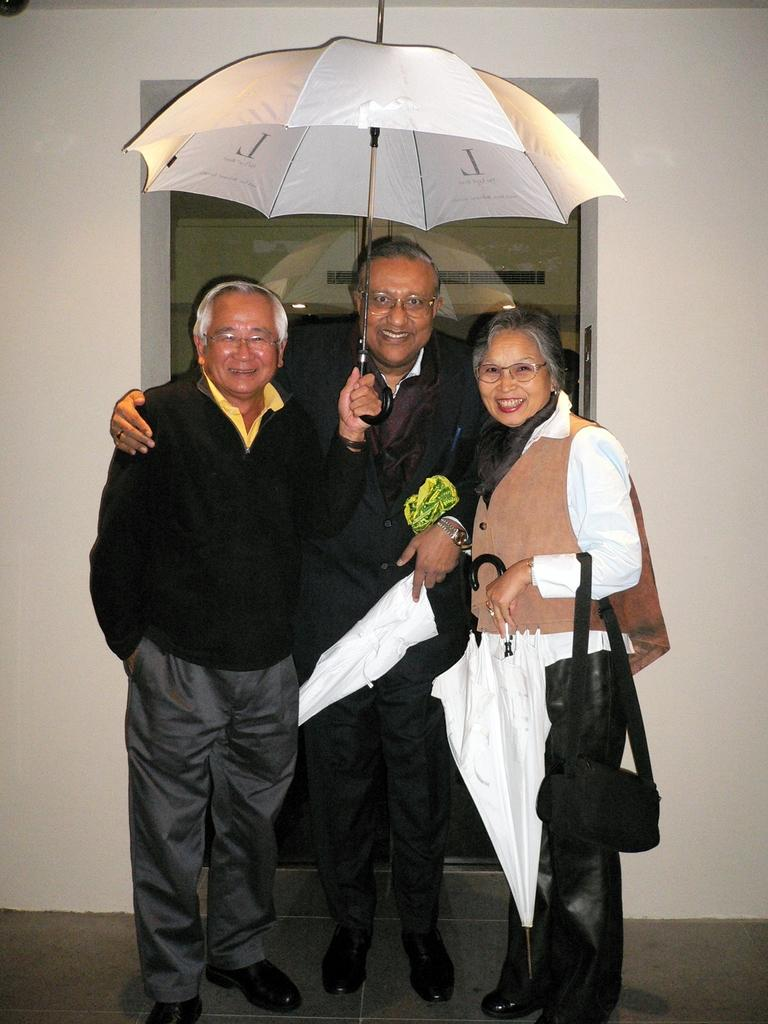How many people are in the image? There are three persons standing in the image. What are the people wearing that is common among them? All three persons are wearing glasses. What are the people holding in the image? All three persons are holding umbrellas. What is the lady holding in addition to the umbrella? The lady is holding a bag. What can be seen in the background of the image? There is a wall with a glass door in the background of the image. How many plants can be seen in the image? There are no plants visible in the image. What type of smile can be seen on the lady's face in the image? There is no indication of a smile on the lady's face in the image, as facial expressions are not clearly visible. 